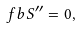Convert formula to latex. <formula><loc_0><loc_0><loc_500><loc_500>\ f b { S } ^ { \prime \prime } = 0 ,</formula> 